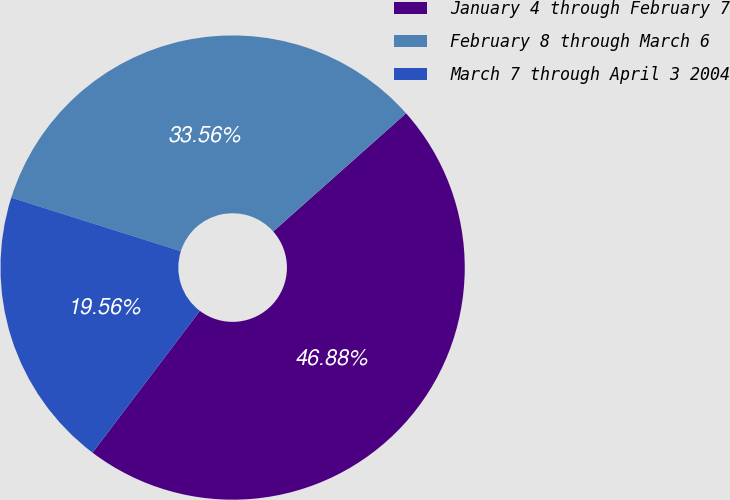Convert chart. <chart><loc_0><loc_0><loc_500><loc_500><pie_chart><fcel>January 4 through February 7<fcel>February 8 through March 6<fcel>March 7 through April 3 2004<nl><fcel>46.88%<fcel>33.56%<fcel>19.56%<nl></chart> 